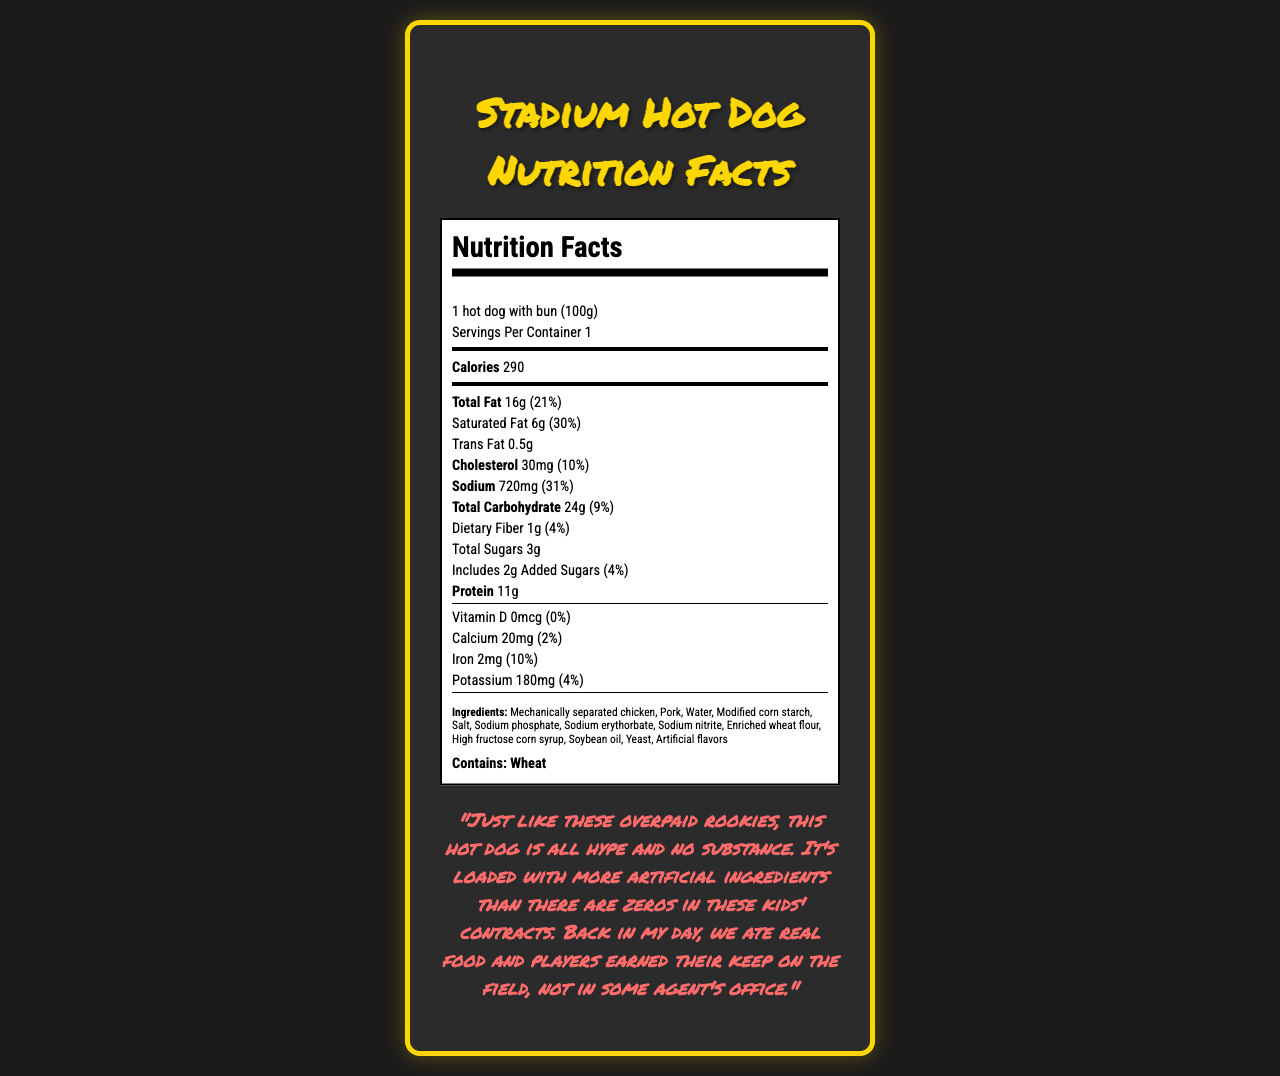what is the serving size of the stadium hot dog? The serving size is specified at the top of the Nutrition Facts label as "1 hot dog with bun (100g)".
Answer: 1 hot dog with bun (100g) how many calories are in one serving of the stadium hot dog? The calories are listed right below the serving size, showing "Calories 290".
Answer: 290 what percentage of the daily value of saturated fat does one hot dog contain? The label states that one hot dog contains 6g of saturated fat, which is 30% of the daily value.
Answer: 30% what is the sodium content in one serving of the hot dog? The label lists the sodium content as 720mg with the daily value percentage alongside it.
Answer: 720mg how much protein is in one hot dog? The amount of protein is specified as 11g in the Nutrition Facts.
Answer: 11g which ingredient is listed first in the hot dog? A. Soybean oil B. Mechanically separated chicken C. High fructose corn syrup The first ingredient listed is "Mechanically separated chicken".
Answer: B what percentage of the daily value of cholesterol does one hot dog provide? A. 5% B. 10% C. 30% The label shows that one hot dog contains 30mg of cholesterol, equating to 10% of the daily value.
Answer: B is there any dietary fiber in this hot dog? The label indicates that the hot dog contains 1g of dietary fiber, which is 4% of the daily value.
Answer: Yes does this hot dog contain any vitamin D? The Nutrition Facts label shows "Vitamin D 0mcg (0%)", indicating it has no vitamin D.
Answer: No briefly summarize the nutritional content and primary ingredients of the stadium hot dog. The summary captures key nutritional values and highlights some of the unhealthy ingredients present in the hot dog.
Answer: The stadium hot dog contains 290 calories, 16g of total fat, 6g of saturated fat, 0.5g trans fat, 30mg cholesterol, 720mg sodium, 24g carbohydrates, 1g dietary fiber, 3g total sugars (including 2g added sugars), and 11g protein. Primary unhealthy ingredients include mechanically separated chicken, sodium erythorbate, and sodium nitrite among several other processed components. are there any allergens listed in the ingredient list? The allergen list specifies "Wheat" as an allergen present in the ingredient list.
Answer: Yes how much total carbohydrate does the hot dog have? The label states the total carbohydrate content as 24g, which is 9% of the daily value.
Answer: 24g what specific commentary is made about the quality of the hot dog? The document includes a cynical commentary comparing the hot dog's poor nutritional value with overpaid rookie players who haven't proven themselves yet.
Answer: "Just like these overpaid rookies, this hot dog is all hype and no substance. It's loaded with more artificial ingredients than there are zeros in these kids' contracts. Back in my day, we ate real food and players earned their keep on the field, not in some agent's office." what type of food has a higher concentration of high fructose corn syrup? The available document does not provide information on the concentration levels of high fructose corn syrup in other foods.
Answer: Cannot be determined 